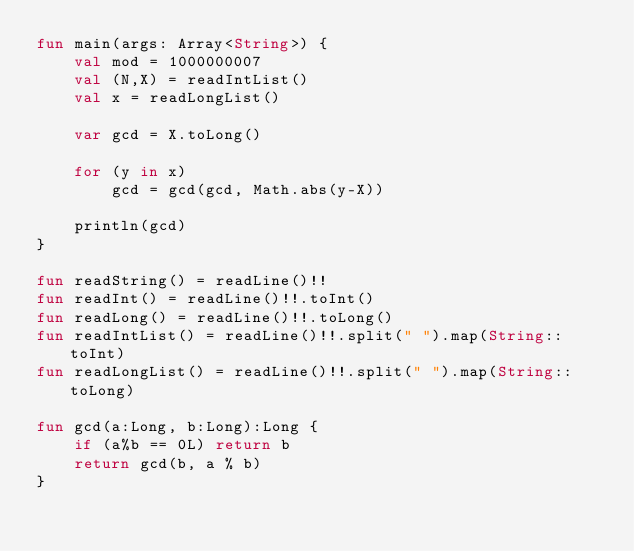<code> <loc_0><loc_0><loc_500><loc_500><_Kotlin_>fun main(args: Array<String>) {
    val mod = 1000000007
    val (N,X) = readIntList()
    val x = readLongList()

    var gcd = X.toLong()

    for (y in x)
        gcd = gcd(gcd, Math.abs(y-X))

    println(gcd)
}

fun readString() = readLine()!!
fun readInt() = readLine()!!.toInt()
fun readLong() = readLine()!!.toLong()
fun readIntList() = readLine()!!.split(" ").map(String::toInt)
fun readLongList() = readLine()!!.split(" ").map(String::toLong)

fun gcd(a:Long, b:Long):Long {
    if (a%b == 0L) return b
    return gcd(b, a % b)
}</code> 